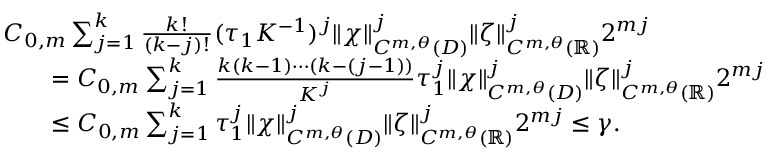Convert formula to latex. <formula><loc_0><loc_0><loc_500><loc_500>\begin{array} { r l } & { C _ { 0 , m } \sum _ { j = 1 } ^ { k } \frac { k ! } { ( k - j ) ! } ( \tau _ { 1 } K ^ { - 1 } ) ^ { j } \| \chi \| _ { C ^ { m , \theta } ( D ) } ^ { j } \| \zeta \| _ { C ^ { m , \theta } ( \mathbb { R } ) } ^ { j } 2 ^ { m j } } \\ & { \quad = C _ { 0 , m } \sum _ { j = 1 } ^ { k } \frac { k ( k - 1 ) \cdots ( k - ( j - 1 ) ) } { K ^ { j } } \tau _ { 1 } ^ { j } \| \chi \| _ { C ^ { m , \theta } ( D ) } ^ { j } \| \zeta \| _ { C ^ { m , \theta } ( \mathbb { R } ) } ^ { j } 2 ^ { m j } } \\ & { \quad \leq C _ { 0 , m } \sum _ { j = 1 } ^ { k } \tau _ { 1 } ^ { j } \| \chi \| _ { C ^ { m , \theta } ( D ) } ^ { j } \| \zeta \| _ { C ^ { m , \theta } ( \mathbb { R } ) } ^ { j } 2 ^ { m j } \leq \gamma . } \end{array}</formula> 